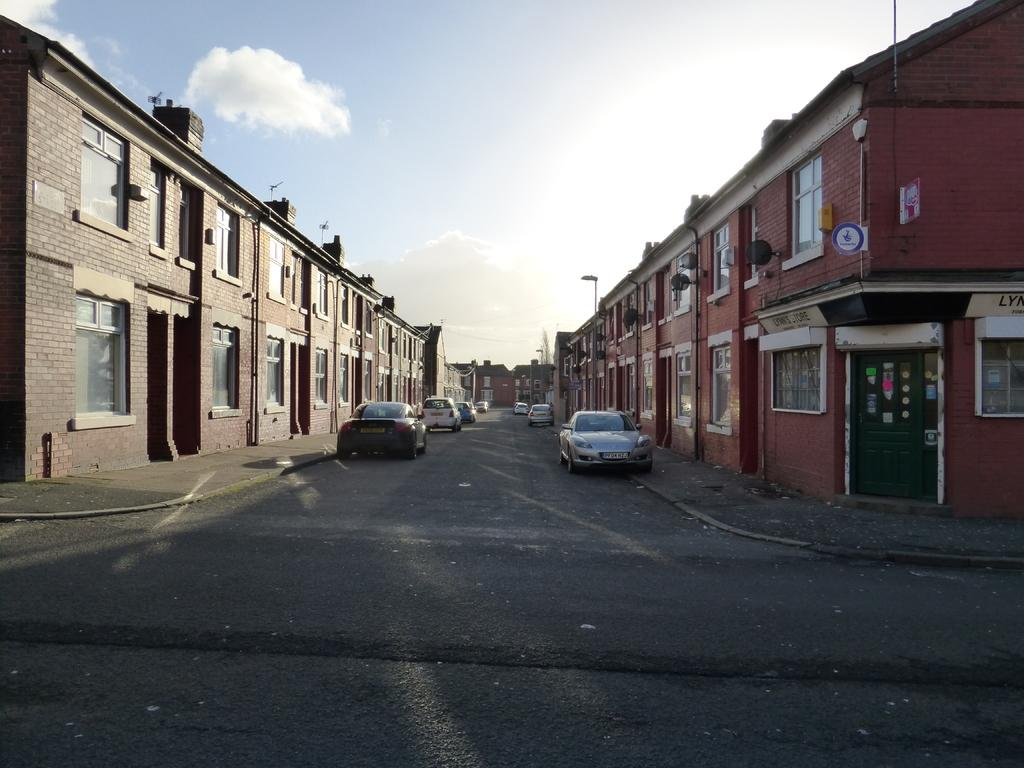What type of structures can be seen in the image? There are buildings in the image. What else can be seen on the ground in the image? There are vehicles on the road in the image. What can be seen in the background of the image? There are poles and clouds visible in the background of the image. What type of basin can be seen in the image? There is no basin present in the image. What is the current situation of the vehicles in the image? The image does not provide information about the current situation or movement of the vehicles. 